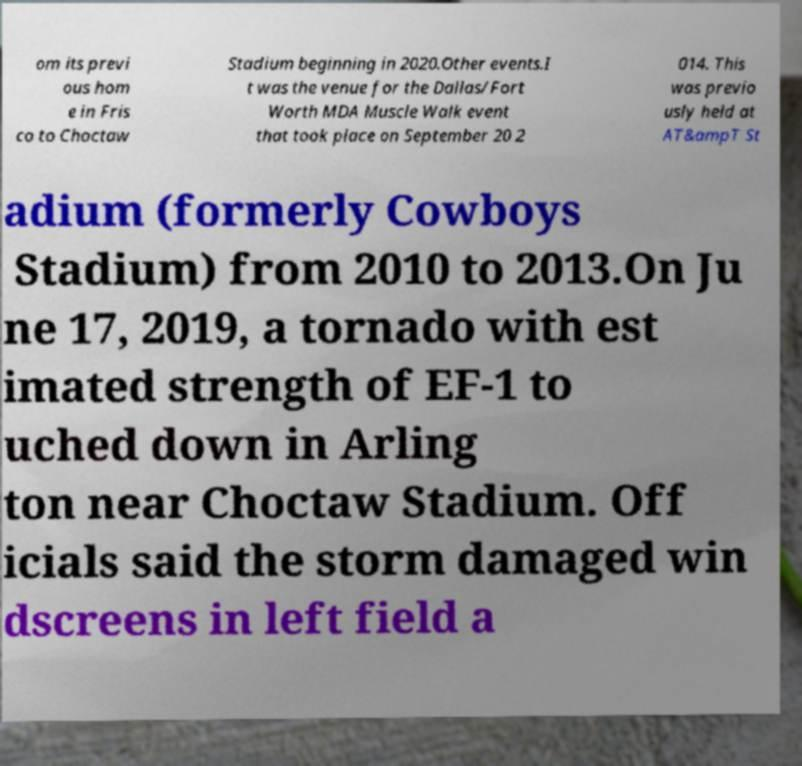Could you extract and type out the text from this image? om its previ ous hom e in Fris co to Choctaw Stadium beginning in 2020.Other events.I t was the venue for the Dallas/Fort Worth MDA Muscle Walk event that took place on September 20 2 014. This was previo usly held at AT&ampT St adium (formerly Cowboys Stadium) from 2010 to 2013.On Ju ne 17, 2019, a tornado with est imated strength of EF-1 to uched down in Arling ton near Choctaw Stadium. Off icials said the storm damaged win dscreens in left field a 